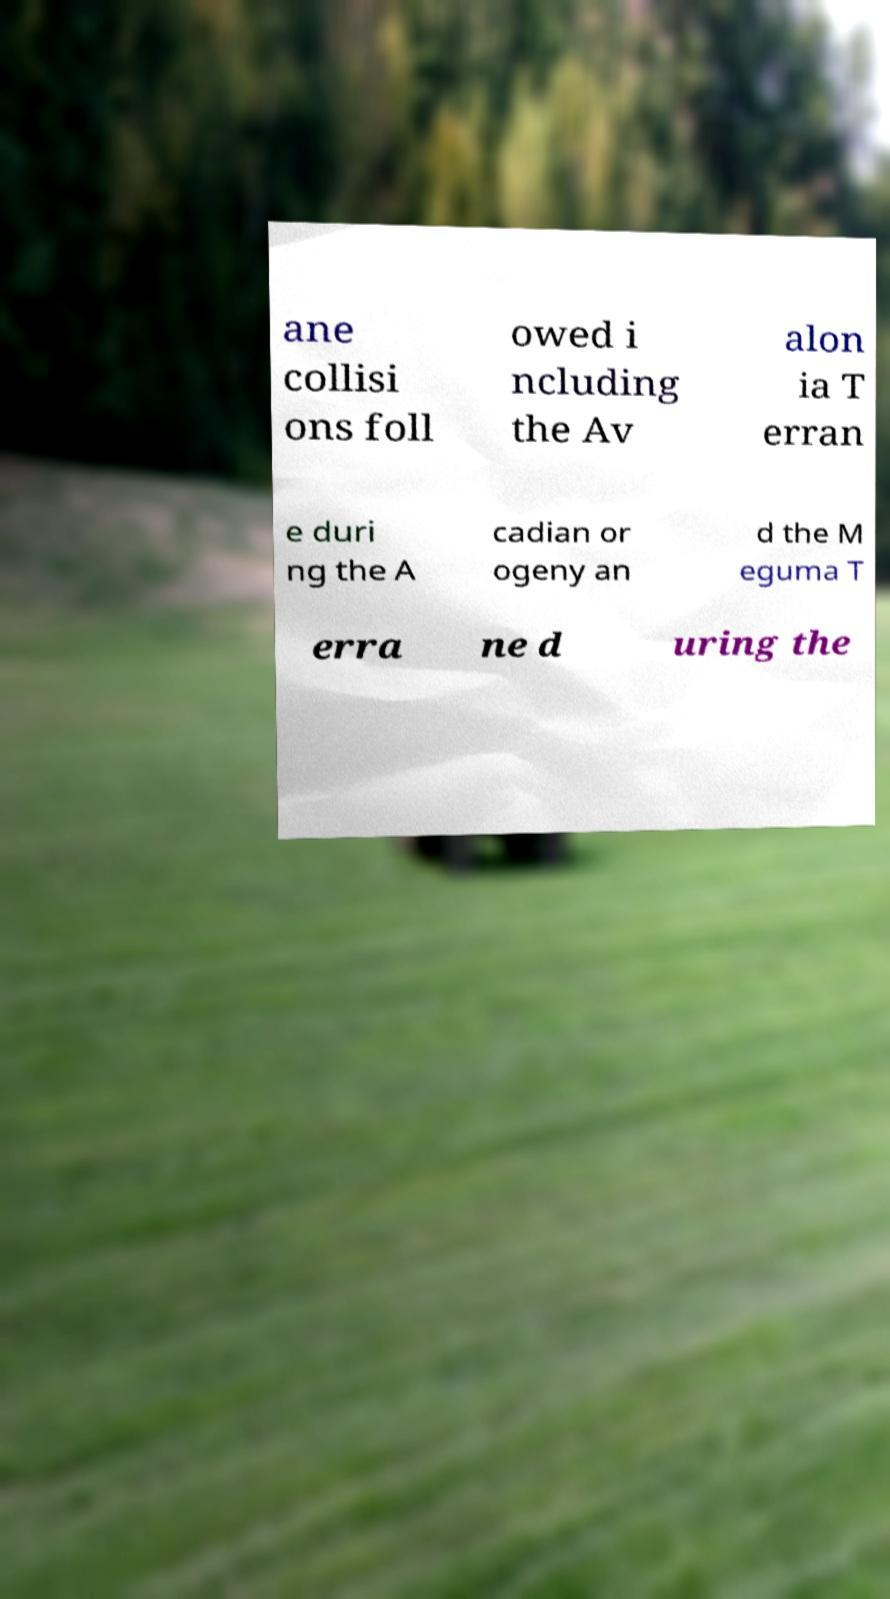Could you extract and type out the text from this image? ane collisi ons foll owed i ncluding the Av alon ia T erran e duri ng the A cadian or ogeny an d the M eguma T erra ne d uring the 